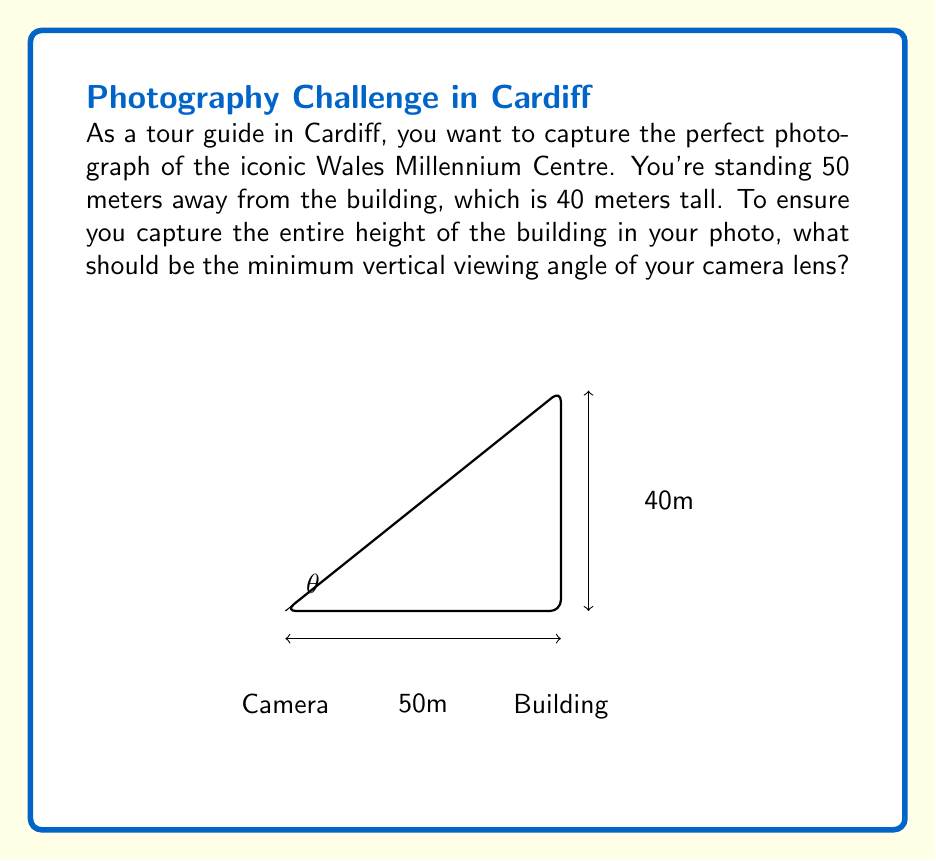What is the answer to this math problem? To solve this problem, we need to use trigonometry. Let's approach this step-by-step:

1) We can treat this scenario as a right-angled triangle, where:
   - The base of the triangle is the distance from the camera to the building (50 meters)
   - The height of the triangle is the height of the building (40 meters)
   - The angle we're looking for is the one formed at the camera position

2) In a right-angled triangle, the tangent of an angle is the ratio of the opposite side to the adjacent side.

3) In our case:
   - The opposite side is the height of the building (40 meters)
   - The adjacent side is the distance from the camera to the building (50 meters)

4) We can express this mathematically as:

   $$\tan(\theta) = \frac{\text{opposite}}{\text{adjacent}} = \frac{40}{50}$$

5) To find the angle θ, we need to take the inverse tangent (arctan or tan^(-1)) of this ratio:

   $$\theta = \tan^{-1}\left(\frac{40}{50}\right)$$

6) Using a calculator or computer:

   $$\theta = \tan^{-1}(0.8) \approx 38.66°$$

7) This is the minimum vertical viewing angle required to capture the entire height of the building.
Answer: $38.66°$ 